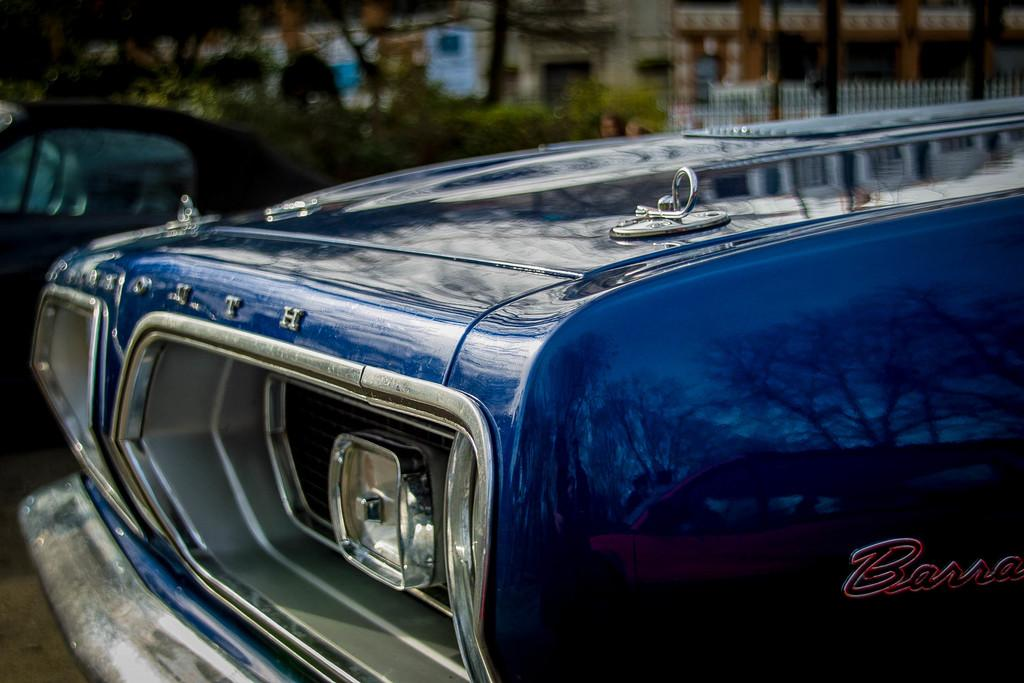How many cars are parked on the road in the image? There are two cars parked on the road in the image. What can be seen in the background of the image? There are trees, a metal fence, and buildings in the background of the image. What type of shirt is the parent wearing in the image? There is no parent or shirt present in the image. How does the lift function in the image? There is no lift present in the image. 